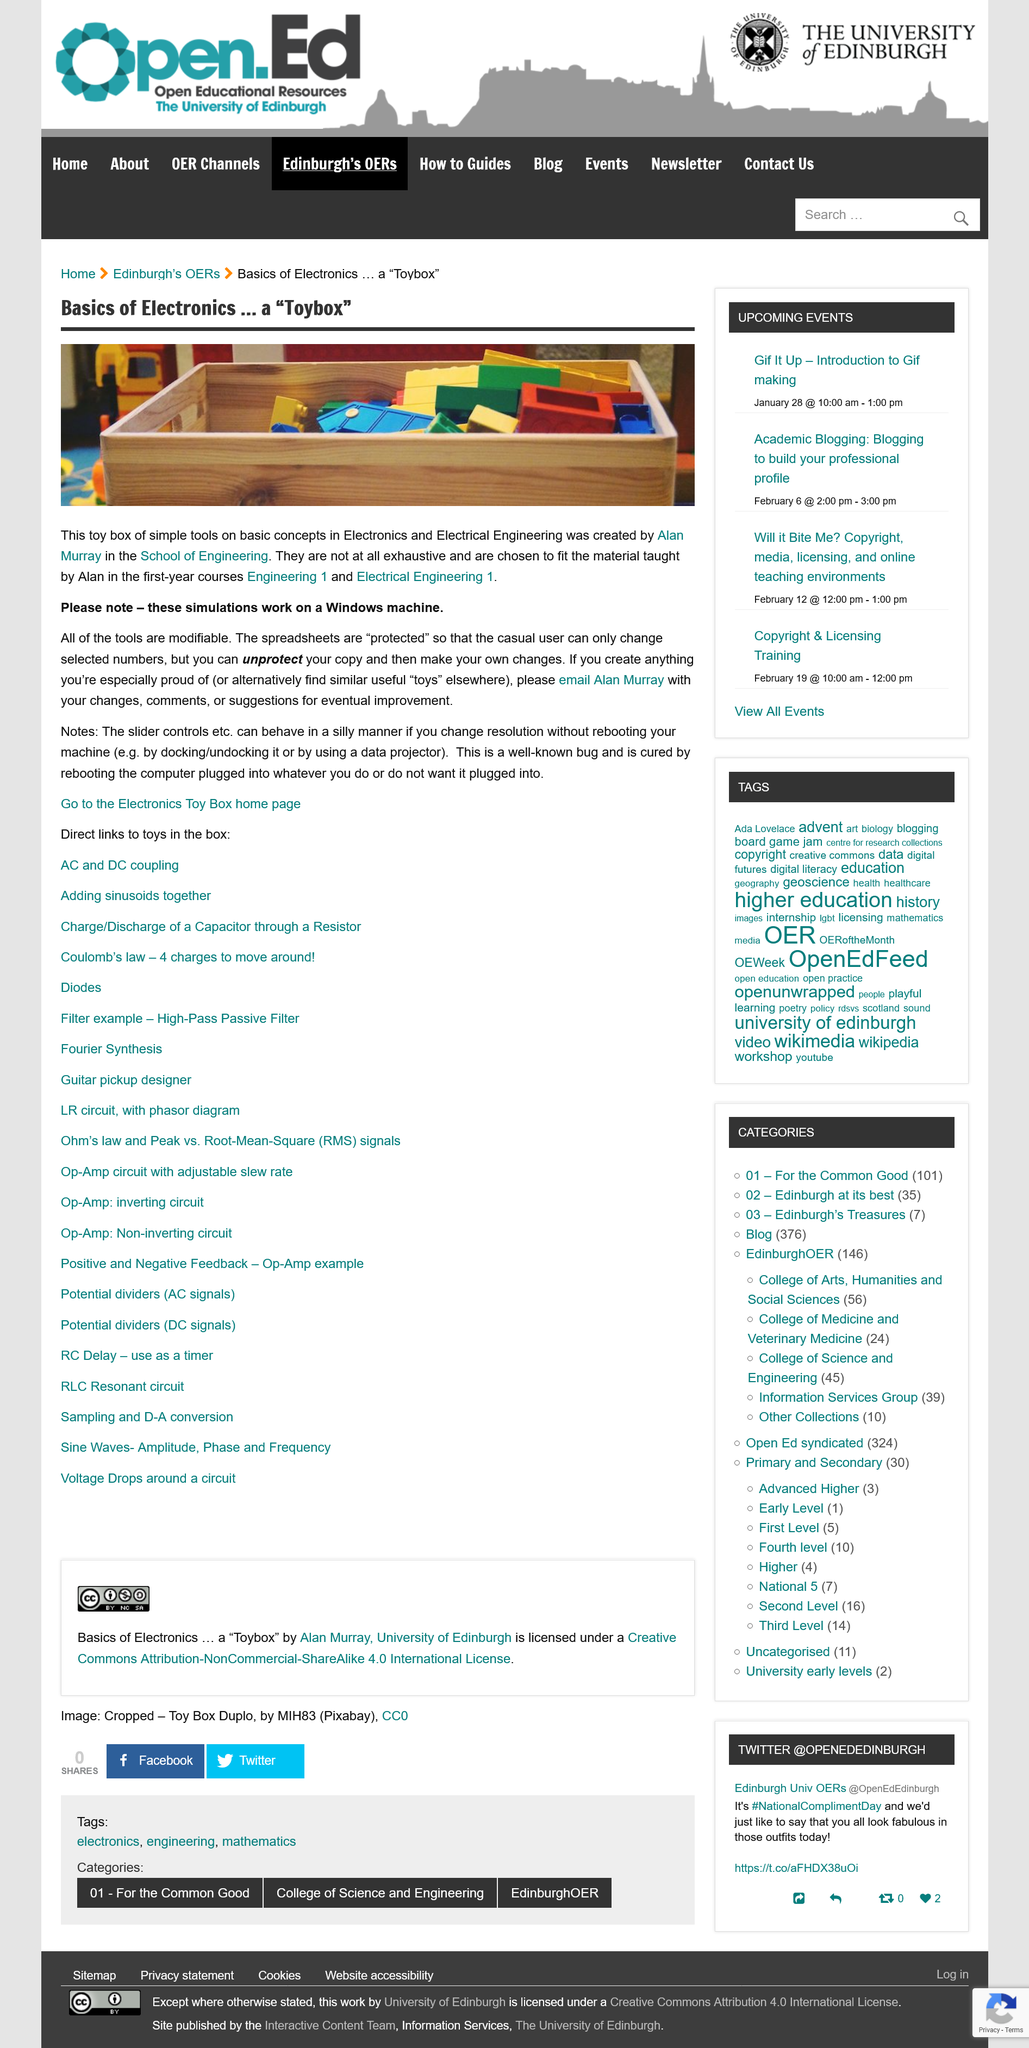Specify some key components in this picture. The design of the software is intended for university students, as it requires a more advanced understanding of computer science concepts and programming skills. However, it could also be beneficial for high school students who have a strong foundation in computer science and are looking for a more challenging learning experience. The software may also be useful for elementary school students who have a natural curiosity for technology and are interested in exploring coding concepts. The simulations work on a Windows machine. 